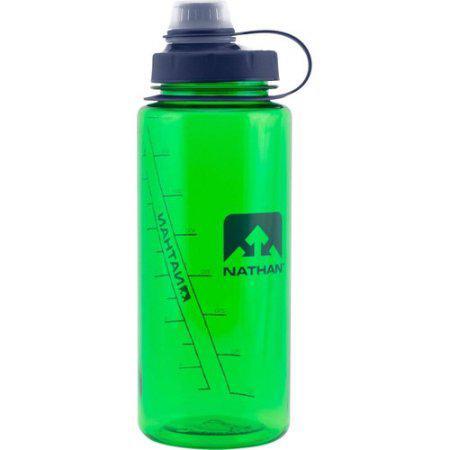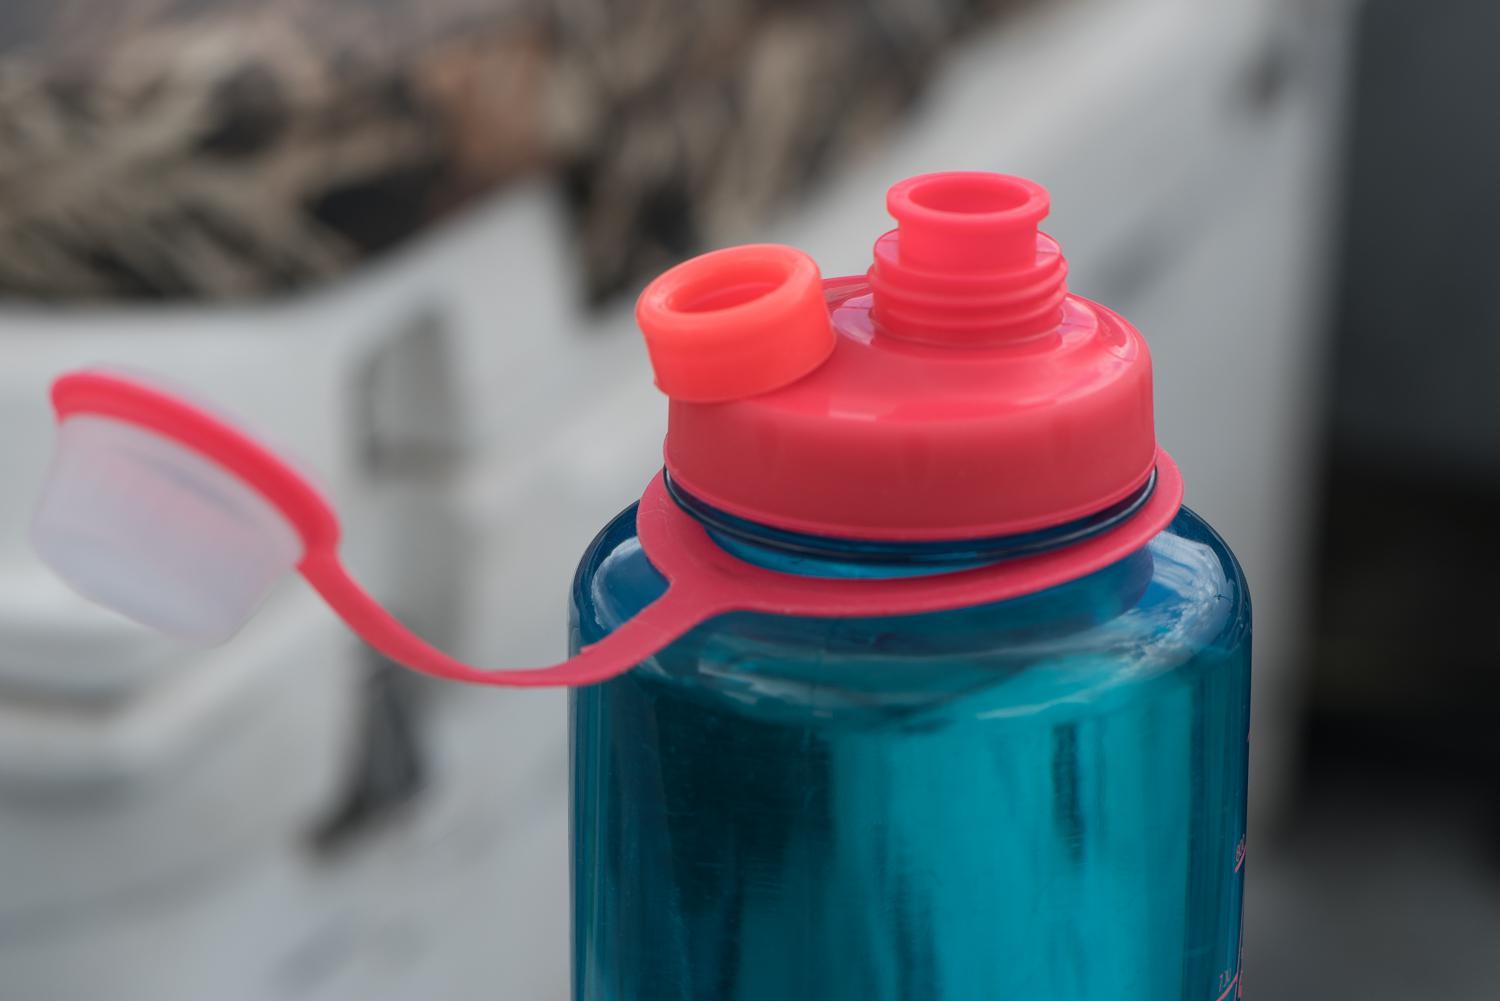The first image is the image on the left, the second image is the image on the right. Analyze the images presented: Is the assertion "There are three water bottles in total." valid? Answer yes or no. No. The first image is the image on the left, the second image is the image on the right. Evaluate the accuracy of this statement regarding the images: "Two bottles are closed.". Is it true? Answer yes or no. No. 